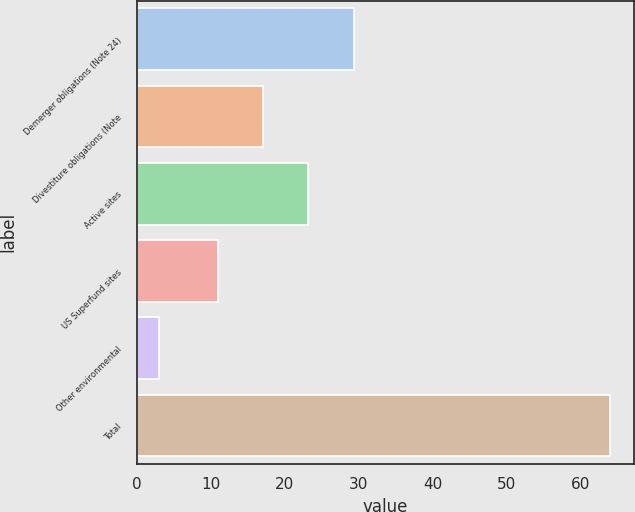Convert chart to OTSL. <chart><loc_0><loc_0><loc_500><loc_500><bar_chart><fcel>Demerger obligations (Note 24)<fcel>Divestiture obligations (Note<fcel>Active sites<fcel>US Superfund sites<fcel>Other environmental<fcel>Total<nl><fcel>29.3<fcel>17.1<fcel>23.2<fcel>11<fcel>3<fcel>64<nl></chart> 